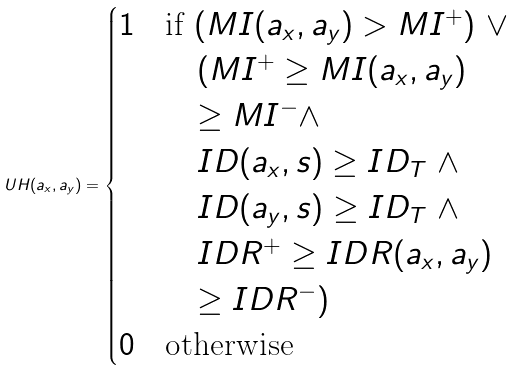<formula> <loc_0><loc_0><loc_500><loc_500>U H ( a _ { x } , a _ { y } ) = \begin{cases} 1 & \text {if $(MI(a_{x},a_{y}) > MI^{+} )$ $\lor$} \\ & \quad \text {$(MI^{+} \geq MI(a_{x},a_{y})$} \\ & \quad \text {$\geq MI^{-}\land$} \\ & \quad \text {$ID(a_{x},s) \geq ID_{T}$ $\land$} \\ & \quad \text {$ID(a_{y},s) \geq ID_{T}$ $\land$} \\ & \quad \text {$IDR^{+} \geq IDR(a_{x},a_{y})$} \\ & \quad \text {$\geq IDR^{-})$} \\ 0 & \text {otherwise} \end{cases}</formula> 